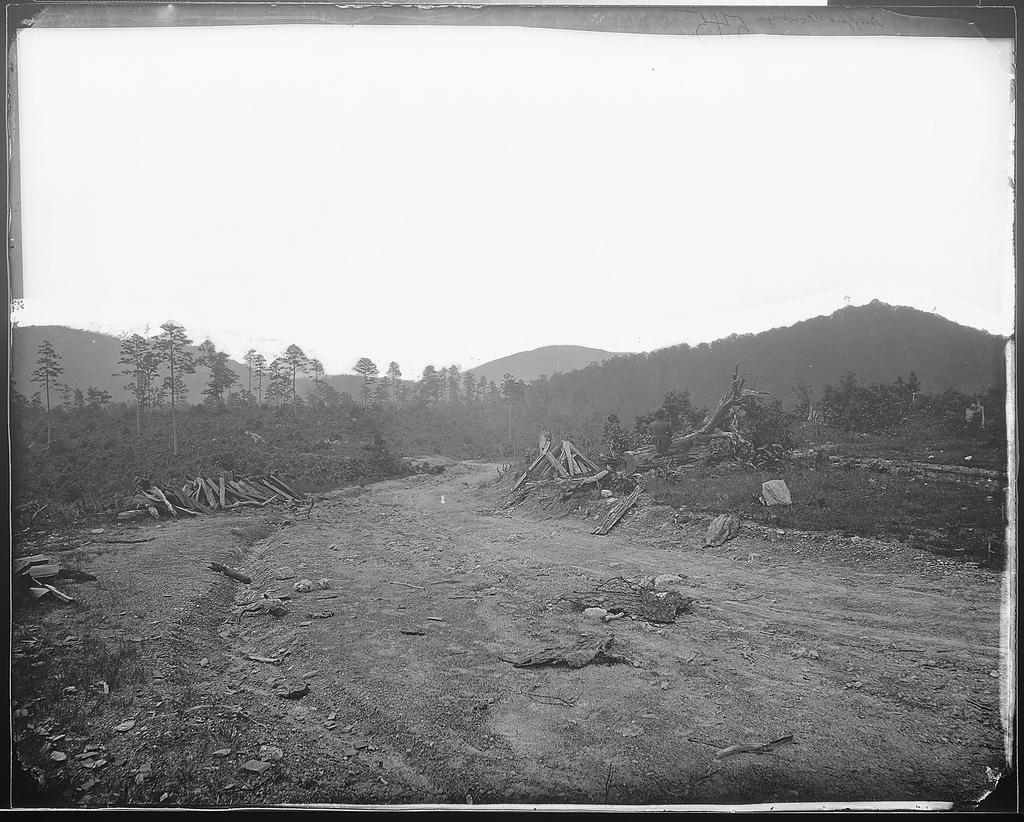In one or two sentences, can you explain what this image depicts? In this picture we can see wooden sticks on the ground, trees, mountains and in the background we can see the sky. 